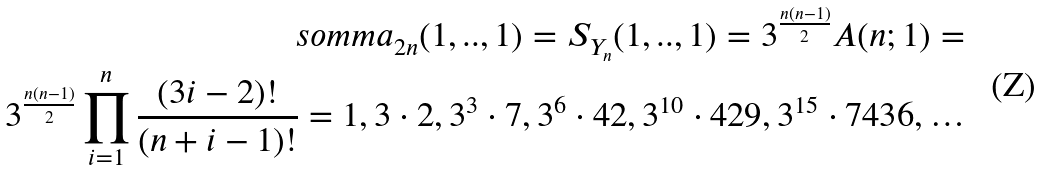Convert formula to latex. <formula><loc_0><loc_0><loc_500><loc_500>\ s o m m a _ { 2 n } ( 1 , . . , 1 ) = S _ { Y _ { n } } ( 1 , . . , 1 ) = 3 ^ { \frac { n ( n - 1 ) } { 2 } } A ( n ; 1 ) = \\ 3 ^ { \frac { n ( n - 1 ) } { 2 } } \prod _ { i = 1 } ^ { n } \frac { ( 3 i - 2 ) ! } { ( n + i - 1 ) ! } = 1 , 3 \cdot 2 , 3 ^ { 3 } \cdot 7 , 3 ^ { 6 } \cdot 4 2 , 3 ^ { 1 0 } \cdot 4 2 9 , 3 ^ { 1 5 } \cdot 7 4 3 6 , \dots</formula> 